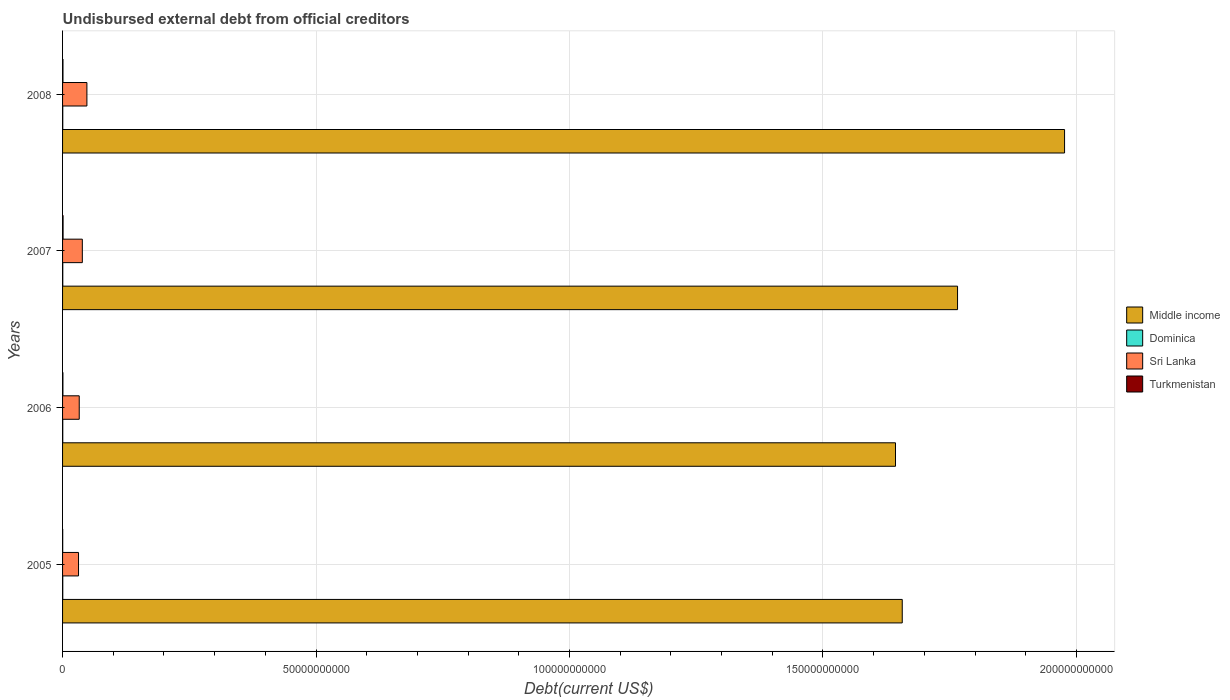How many bars are there on the 4th tick from the top?
Keep it short and to the point. 4. How many bars are there on the 1st tick from the bottom?
Offer a very short reply. 4. What is the label of the 4th group of bars from the top?
Your answer should be very brief. 2005. In how many cases, is the number of bars for a given year not equal to the number of legend labels?
Your answer should be very brief. 0. What is the total debt in Dominica in 2007?
Make the answer very short. 4.27e+07. Across all years, what is the maximum total debt in Turkmenistan?
Provide a short and direct response. 1.02e+08. Across all years, what is the minimum total debt in Middle income?
Offer a very short reply. 1.64e+11. What is the total total debt in Sri Lanka in the graph?
Your answer should be very brief. 1.51e+1. What is the difference between the total debt in Dominica in 2006 and that in 2008?
Provide a short and direct response. 1.74e+05. What is the difference between the total debt in Sri Lanka in 2005 and the total debt in Turkmenistan in 2008?
Your answer should be very brief. 3.07e+09. What is the average total debt in Middle income per year?
Offer a very short reply. 1.76e+11. In the year 2008, what is the difference between the total debt in Sri Lanka and total debt in Middle income?
Give a very brief answer. -1.93e+11. In how many years, is the total debt in Dominica greater than 80000000000 US$?
Provide a succinct answer. 0. What is the ratio of the total debt in Sri Lanka in 2007 to that in 2008?
Your answer should be very brief. 0.81. Is the total debt in Turkmenistan in 2006 less than that in 2008?
Ensure brevity in your answer.  Yes. What is the difference between the highest and the second highest total debt in Sri Lanka?
Provide a succinct answer. 9.03e+08. What is the difference between the highest and the lowest total debt in Turkmenistan?
Give a very brief answer. 7.60e+07. Is it the case that in every year, the sum of the total debt in Turkmenistan and total debt in Sri Lanka is greater than the sum of total debt in Middle income and total debt in Dominica?
Your response must be concise. No. What does the 1st bar from the top in 2005 represents?
Give a very brief answer. Turkmenistan. Are the values on the major ticks of X-axis written in scientific E-notation?
Provide a short and direct response. No. Does the graph contain any zero values?
Offer a terse response. No. Does the graph contain grids?
Your response must be concise. Yes. Where does the legend appear in the graph?
Keep it short and to the point. Center right. How many legend labels are there?
Offer a very short reply. 4. What is the title of the graph?
Offer a very short reply. Undisbursed external debt from official creditors. What is the label or title of the X-axis?
Keep it short and to the point. Debt(current US$). What is the Debt(current US$) in Middle income in 2005?
Ensure brevity in your answer.  1.66e+11. What is the Debt(current US$) in Dominica in 2005?
Offer a very short reply. 3.99e+07. What is the Debt(current US$) of Sri Lanka in 2005?
Your answer should be very brief. 3.15e+09. What is the Debt(current US$) in Turkmenistan in 2005?
Offer a terse response. 2.61e+07. What is the Debt(current US$) in Middle income in 2006?
Offer a very short reply. 1.64e+11. What is the Debt(current US$) of Dominica in 2006?
Your answer should be very brief. 3.87e+07. What is the Debt(current US$) in Sri Lanka in 2006?
Your answer should be very brief. 3.29e+09. What is the Debt(current US$) in Turkmenistan in 2006?
Provide a succinct answer. 6.93e+07. What is the Debt(current US$) in Middle income in 2007?
Provide a short and direct response. 1.77e+11. What is the Debt(current US$) in Dominica in 2007?
Offer a very short reply. 4.27e+07. What is the Debt(current US$) of Sri Lanka in 2007?
Make the answer very short. 3.90e+09. What is the Debt(current US$) of Turkmenistan in 2007?
Your answer should be compact. 1.02e+08. What is the Debt(current US$) in Middle income in 2008?
Give a very brief answer. 1.98e+11. What is the Debt(current US$) in Dominica in 2008?
Give a very brief answer. 3.85e+07. What is the Debt(current US$) in Sri Lanka in 2008?
Provide a succinct answer. 4.80e+09. What is the Debt(current US$) of Turkmenistan in 2008?
Provide a succinct answer. 8.30e+07. Across all years, what is the maximum Debt(current US$) of Middle income?
Keep it short and to the point. 1.98e+11. Across all years, what is the maximum Debt(current US$) in Dominica?
Provide a short and direct response. 4.27e+07. Across all years, what is the maximum Debt(current US$) in Sri Lanka?
Keep it short and to the point. 4.80e+09. Across all years, what is the maximum Debt(current US$) of Turkmenistan?
Your answer should be very brief. 1.02e+08. Across all years, what is the minimum Debt(current US$) in Middle income?
Your answer should be compact. 1.64e+11. Across all years, what is the minimum Debt(current US$) in Dominica?
Give a very brief answer. 3.85e+07. Across all years, what is the minimum Debt(current US$) in Sri Lanka?
Keep it short and to the point. 3.15e+09. Across all years, what is the minimum Debt(current US$) in Turkmenistan?
Provide a succinct answer. 2.61e+07. What is the total Debt(current US$) of Middle income in the graph?
Provide a short and direct response. 7.04e+11. What is the total Debt(current US$) of Dominica in the graph?
Your response must be concise. 1.60e+08. What is the total Debt(current US$) in Sri Lanka in the graph?
Your answer should be very brief. 1.51e+1. What is the total Debt(current US$) of Turkmenistan in the graph?
Make the answer very short. 2.81e+08. What is the difference between the Debt(current US$) of Middle income in 2005 and that in 2006?
Offer a terse response. 1.33e+09. What is the difference between the Debt(current US$) in Dominica in 2005 and that in 2006?
Give a very brief answer. 1.27e+06. What is the difference between the Debt(current US$) in Sri Lanka in 2005 and that in 2006?
Your answer should be very brief. -1.40e+08. What is the difference between the Debt(current US$) in Turkmenistan in 2005 and that in 2006?
Provide a succinct answer. -4.32e+07. What is the difference between the Debt(current US$) of Middle income in 2005 and that in 2007?
Your answer should be compact. -1.09e+1. What is the difference between the Debt(current US$) in Dominica in 2005 and that in 2007?
Make the answer very short. -2.81e+06. What is the difference between the Debt(current US$) of Sri Lanka in 2005 and that in 2007?
Your response must be concise. -7.50e+08. What is the difference between the Debt(current US$) of Turkmenistan in 2005 and that in 2007?
Give a very brief answer. -7.60e+07. What is the difference between the Debt(current US$) of Middle income in 2005 and that in 2008?
Make the answer very short. -3.20e+1. What is the difference between the Debt(current US$) of Dominica in 2005 and that in 2008?
Provide a short and direct response. 1.45e+06. What is the difference between the Debt(current US$) of Sri Lanka in 2005 and that in 2008?
Give a very brief answer. -1.65e+09. What is the difference between the Debt(current US$) of Turkmenistan in 2005 and that in 2008?
Ensure brevity in your answer.  -5.69e+07. What is the difference between the Debt(current US$) in Middle income in 2006 and that in 2007?
Make the answer very short. -1.22e+1. What is the difference between the Debt(current US$) of Dominica in 2006 and that in 2007?
Offer a terse response. -4.09e+06. What is the difference between the Debt(current US$) of Sri Lanka in 2006 and that in 2007?
Ensure brevity in your answer.  -6.10e+08. What is the difference between the Debt(current US$) of Turkmenistan in 2006 and that in 2007?
Give a very brief answer. -3.28e+07. What is the difference between the Debt(current US$) in Middle income in 2006 and that in 2008?
Ensure brevity in your answer.  -3.34e+1. What is the difference between the Debt(current US$) in Dominica in 2006 and that in 2008?
Give a very brief answer. 1.74e+05. What is the difference between the Debt(current US$) in Sri Lanka in 2006 and that in 2008?
Provide a succinct answer. -1.51e+09. What is the difference between the Debt(current US$) in Turkmenistan in 2006 and that in 2008?
Offer a terse response. -1.38e+07. What is the difference between the Debt(current US$) of Middle income in 2007 and that in 2008?
Offer a terse response. -2.11e+1. What is the difference between the Debt(current US$) of Dominica in 2007 and that in 2008?
Ensure brevity in your answer.  4.26e+06. What is the difference between the Debt(current US$) of Sri Lanka in 2007 and that in 2008?
Make the answer very short. -9.03e+08. What is the difference between the Debt(current US$) in Turkmenistan in 2007 and that in 2008?
Your answer should be compact. 1.91e+07. What is the difference between the Debt(current US$) in Middle income in 2005 and the Debt(current US$) in Dominica in 2006?
Offer a terse response. 1.66e+11. What is the difference between the Debt(current US$) of Middle income in 2005 and the Debt(current US$) of Sri Lanka in 2006?
Offer a terse response. 1.62e+11. What is the difference between the Debt(current US$) in Middle income in 2005 and the Debt(current US$) in Turkmenistan in 2006?
Offer a very short reply. 1.66e+11. What is the difference between the Debt(current US$) of Dominica in 2005 and the Debt(current US$) of Sri Lanka in 2006?
Ensure brevity in your answer.  -3.25e+09. What is the difference between the Debt(current US$) of Dominica in 2005 and the Debt(current US$) of Turkmenistan in 2006?
Make the answer very short. -2.93e+07. What is the difference between the Debt(current US$) in Sri Lanka in 2005 and the Debt(current US$) in Turkmenistan in 2006?
Your answer should be compact. 3.08e+09. What is the difference between the Debt(current US$) in Middle income in 2005 and the Debt(current US$) in Dominica in 2007?
Provide a short and direct response. 1.66e+11. What is the difference between the Debt(current US$) of Middle income in 2005 and the Debt(current US$) of Sri Lanka in 2007?
Your response must be concise. 1.62e+11. What is the difference between the Debt(current US$) of Middle income in 2005 and the Debt(current US$) of Turkmenistan in 2007?
Provide a succinct answer. 1.66e+11. What is the difference between the Debt(current US$) of Dominica in 2005 and the Debt(current US$) of Sri Lanka in 2007?
Your response must be concise. -3.86e+09. What is the difference between the Debt(current US$) of Dominica in 2005 and the Debt(current US$) of Turkmenistan in 2007?
Your response must be concise. -6.22e+07. What is the difference between the Debt(current US$) in Sri Lanka in 2005 and the Debt(current US$) in Turkmenistan in 2007?
Make the answer very short. 3.05e+09. What is the difference between the Debt(current US$) in Middle income in 2005 and the Debt(current US$) in Dominica in 2008?
Your answer should be compact. 1.66e+11. What is the difference between the Debt(current US$) of Middle income in 2005 and the Debt(current US$) of Sri Lanka in 2008?
Give a very brief answer. 1.61e+11. What is the difference between the Debt(current US$) of Middle income in 2005 and the Debt(current US$) of Turkmenistan in 2008?
Your response must be concise. 1.66e+11. What is the difference between the Debt(current US$) in Dominica in 2005 and the Debt(current US$) in Sri Lanka in 2008?
Make the answer very short. -4.76e+09. What is the difference between the Debt(current US$) in Dominica in 2005 and the Debt(current US$) in Turkmenistan in 2008?
Offer a very short reply. -4.31e+07. What is the difference between the Debt(current US$) in Sri Lanka in 2005 and the Debt(current US$) in Turkmenistan in 2008?
Make the answer very short. 3.07e+09. What is the difference between the Debt(current US$) in Middle income in 2006 and the Debt(current US$) in Dominica in 2007?
Give a very brief answer. 1.64e+11. What is the difference between the Debt(current US$) in Middle income in 2006 and the Debt(current US$) in Sri Lanka in 2007?
Make the answer very short. 1.60e+11. What is the difference between the Debt(current US$) in Middle income in 2006 and the Debt(current US$) in Turkmenistan in 2007?
Your answer should be compact. 1.64e+11. What is the difference between the Debt(current US$) of Dominica in 2006 and the Debt(current US$) of Sri Lanka in 2007?
Offer a very short reply. -3.86e+09. What is the difference between the Debt(current US$) in Dominica in 2006 and the Debt(current US$) in Turkmenistan in 2007?
Your answer should be compact. -6.34e+07. What is the difference between the Debt(current US$) in Sri Lanka in 2006 and the Debt(current US$) in Turkmenistan in 2007?
Your response must be concise. 3.19e+09. What is the difference between the Debt(current US$) of Middle income in 2006 and the Debt(current US$) of Dominica in 2008?
Offer a terse response. 1.64e+11. What is the difference between the Debt(current US$) in Middle income in 2006 and the Debt(current US$) in Sri Lanka in 2008?
Make the answer very short. 1.60e+11. What is the difference between the Debt(current US$) of Middle income in 2006 and the Debt(current US$) of Turkmenistan in 2008?
Offer a terse response. 1.64e+11. What is the difference between the Debt(current US$) in Dominica in 2006 and the Debt(current US$) in Sri Lanka in 2008?
Provide a succinct answer. -4.76e+09. What is the difference between the Debt(current US$) in Dominica in 2006 and the Debt(current US$) in Turkmenistan in 2008?
Offer a terse response. -4.44e+07. What is the difference between the Debt(current US$) of Sri Lanka in 2006 and the Debt(current US$) of Turkmenistan in 2008?
Provide a short and direct response. 3.21e+09. What is the difference between the Debt(current US$) of Middle income in 2007 and the Debt(current US$) of Dominica in 2008?
Provide a short and direct response. 1.77e+11. What is the difference between the Debt(current US$) of Middle income in 2007 and the Debt(current US$) of Sri Lanka in 2008?
Provide a short and direct response. 1.72e+11. What is the difference between the Debt(current US$) in Middle income in 2007 and the Debt(current US$) in Turkmenistan in 2008?
Make the answer very short. 1.76e+11. What is the difference between the Debt(current US$) in Dominica in 2007 and the Debt(current US$) in Sri Lanka in 2008?
Your answer should be compact. -4.76e+09. What is the difference between the Debt(current US$) of Dominica in 2007 and the Debt(current US$) of Turkmenistan in 2008?
Make the answer very short. -4.03e+07. What is the difference between the Debt(current US$) in Sri Lanka in 2007 and the Debt(current US$) in Turkmenistan in 2008?
Make the answer very short. 3.82e+09. What is the average Debt(current US$) of Middle income per year?
Your response must be concise. 1.76e+11. What is the average Debt(current US$) of Dominica per year?
Ensure brevity in your answer.  4.00e+07. What is the average Debt(current US$) in Sri Lanka per year?
Keep it short and to the point. 3.78e+09. What is the average Debt(current US$) of Turkmenistan per year?
Your response must be concise. 7.01e+07. In the year 2005, what is the difference between the Debt(current US$) of Middle income and Debt(current US$) of Dominica?
Your response must be concise. 1.66e+11. In the year 2005, what is the difference between the Debt(current US$) in Middle income and Debt(current US$) in Sri Lanka?
Offer a terse response. 1.62e+11. In the year 2005, what is the difference between the Debt(current US$) in Middle income and Debt(current US$) in Turkmenistan?
Offer a terse response. 1.66e+11. In the year 2005, what is the difference between the Debt(current US$) in Dominica and Debt(current US$) in Sri Lanka?
Make the answer very short. -3.11e+09. In the year 2005, what is the difference between the Debt(current US$) of Dominica and Debt(current US$) of Turkmenistan?
Your answer should be compact. 1.38e+07. In the year 2005, what is the difference between the Debt(current US$) of Sri Lanka and Debt(current US$) of Turkmenistan?
Your response must be concise. 3.12e+09. In the year 2006, what is the difference between the Debt(current US$) in Middle income and Debt(current US$) in Dominica?
Provide a short and direct response. 1.64e+11. In the year 2006, what is the difference between the Debt(current US$) of Middle income and Debt(current US$) of Sri Lanka?
Make the answer very short. 1.61e+11. In the year 2006, what is the difference between the Debt(current US$) of Middle income and Debt(current US$) of Turkmenistan?
Your answer should be very brief. 1.64e+11. In the year 2006, what is the difference between the Debt(current US$) in Dominica and Debt(current US$) in Sri Lanka?
Keep it short and to the point. -3.25e+09. In the year 2006, what is the difference between the Debt(current US$) of Dominica and Debt(current US$) of Turkmenistan?
Provide a succinct answer. -3.06e+07. In the year 2006, what is the difference between the Debt(current US$) in Sri Lanka and Debt(current US$) in Turkmenistan?
Your response must be concise. 3.22e+09. In the year 2007, what is the difference between the Debt(current US$) in Middle income and Debt(current US$) in Dominica?
Your answer should be compact. 1.77e+11. In the year 2007, what is the difference between the Debt(current US$) of Middle income and Debt(current US$) of Sri Lanka?
Your answer should be very brief. 1.73e+11. In the year 2007, what is the difference between the Debt(current US$) of Middle income and Debt(current US$) of Turkmenistan?
Keep it short and to the point. 1.76e+11. In the year 2007, what is the difference between the Debt(current US$) in Dominica and Debt(current US$) in Sri Lanka?
Offer a terse response. -3.86e+09. In the year 2007, what is the difference between the Debt(current US$) of Dominica and Debt(current US$) of Turkmenistan?
Your response must be concise. -5.94e+07. In the year 2007, what is the difference between the Debt(current US$) of Sri Lanka and Debt(current US$) of Turkmenistan?
Make the answer very short. 3.80e+09. In the year 2008, what is the difference between the Debt(current US$) of Middle income and Debt(current US$) of Dominica?
Your answer should be compact. 1.98e+11. In the year 2008, what is the difference between the Debt(current US$) of Middle income and Debt(current US$) of Sri Lanka?
Keep it short and to the point. 1.93e+11. In the year 2008, what is the difference between the Debt(current US$) of Middle income and Debt(current US$) of Turkmenistan?
Provide a succinct answer. 1.98e+11. In the year 2008, what is the difference between the Debt(current US$) in Dominica and Debt(current US$) in Sri Lanka?
Offer a terse response. -4.76e+09. In the year 2008, what is the difference between the Debt(current US$) in Dominica and Debt(current US$) in Turkmenistan?
Provide a short and direct response. -4.45e+07. In the year 2008, what is the difference between the Debt(current US$) of Sri Lanka and Debt(current US$) of Turkmenistan?
Offer a very short reply. 4.72e+09. What is the ratio of the Debt(current US$) of Dominica in 2005 to that in 2006?
Offer a very short reply. 1.03. What is the ratio of the Debt(current US$) of Sri Lanka in 2005 to that in 2006?
Give a very brief answer. 0.96. What is the ratio of the Debt(current US$) in Turkmenistan in 2005 to that in 2006?
Keep it short and to the point. 0.38. What is the ratio of the Debt(current US$) of Middle income in 2005 to that in 2007?
Provide a succinct answer. 0.94. What is the ratio of the Debt(current US$) in Dominica in 2005 to that in 2007?
Offer a very short reply. 0.93. What is the ratio of the Debt(current US$) in Sri Lanka in 2005 to that in 2007?
Give a very brief answer. 0.81. What is the ratio of the Debt(current US$) in Turkmenistan in 2005 to that in 2007?
Your response must be concise. 0.26. What is the ratio of the Debt(current US$) in Middle income in 2005 to that in 2008?
Offer a terse response. 0.84. What is the ratio of the Debt(current US$) in Dominica in 2005 to that in 2008?
Ensure brevity in your answer.  1.04. What is the ratio of the Debt(current US$) of Sri Lanka in 2005 to that in 2008?
Ensure brevity in your answer.  0.66. What is the ratio of the Debt(current US$) of Turkmenistan in 2005 to that in 2008?
Keep it short and to the point. 0.31. What is the ratio of the Debt(current US$) of Middle income in 2006 to that in 2007?
Ensure brevity in your answer.  0.93. What is the ratio of the Debt(current US$) of Dominica in 2006 to that in 2007?
Your answer should be compact. 0.9. What is the ratio of the Debt(current US$) of Sri Lanka in 2006 to that in 2007?
Ensure brevity in your answer.  0.84. What is the ratio of the Debt(current US$) of Turkmenistan in 2006 to that in 2007?
Ensure brevity in your answer.  0.68. What is the ratio of the Debt(current US$) in Middle income in 2006 to that in 2008?
Provide a short and direct response. 0.83. What is the ratio of the Debt(current US$) in Dominica in 2006 to that in 2008?
Provide a succinct answer. 1. What is the ratio of the Debt(current US$) in Sri Lanka in 2006 to that in 2008?
Provide a short and direct response. 0.68. What is the ratio of the Debt(current US$) of Turkmenistan in 2006 to that in 2008?
Keep it short and to the point. 0.83. What is the ratio of the Debt(current US$) of Middle income in 2007 to that in 2008?
Ensure brevity in your answer.  0.89. What is the ratio of the Debt(current US$) in Dominica in 2007 to that in 2008?
Make the answer very short. 1.11. What is the ratio of the Debt(current US$) of Sri Lanka in 2007 to that in 2008?
Provide a short and direct response. 0.81. What is the ratio of the Debt(current US$) of Turkmenistan in 2007 to that in 2008?
Make the answer very short. 1.23. What is the difference between the highest and the second highest Debt(current US$) of Middle income?
Provide a short and direct response. 2.11e+1. What is the difference between the highest and the second highest Debt(current US$) in Dominica?
Provide a short and direct response. 2.81e+06. What is the difference between the highest and the second highest Debt(current US$) of Sri Lanka?
Keep it short and to the point. 9.03e+08. What is the difference between the highest and the second highest Debt(current US$) in Turkmenistan?
Ensure brevity in your answer.  1.91e+07. What is the difference between the highest and the lowest Debt(current US$) in Middle income?
Provide a succinct answer. 3.34e+1. What is the difference between the highest and the lowest Debt(current US$) in Dominica?
Keep it short and to the point. 4.26e+06. What is the difference between the highest and the lowest Debt(current US$) in Sri Lanka?
Ensure brevity in your answer.  1.65e+09. What is the difference between the highest and the lowest Debt(current US$) of Turkmenistan?
Keep it short and to the point. 7.60e+07. 